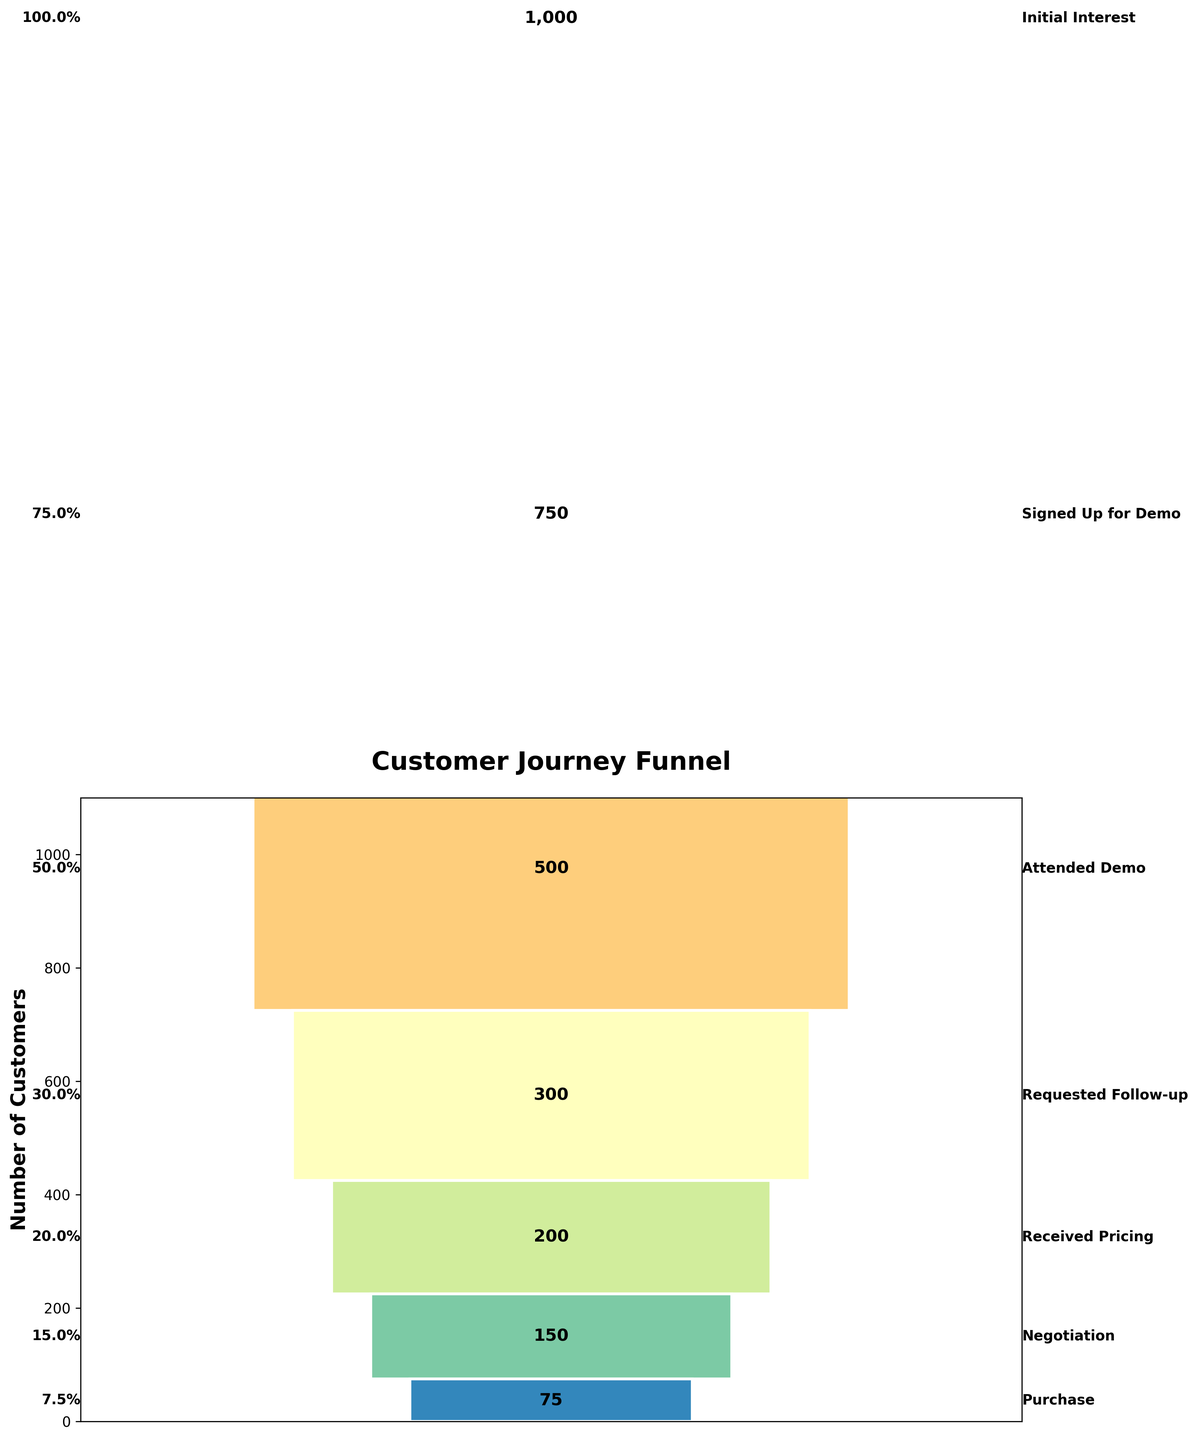What's the title of the funnel chart? The title is usually placed at the top of the chart. The figure shows "Customer Journey Funnel" as the title, positioned prominently at the top of the chart.
Answer: Customer Journey Funnel How many customers signed up for the demo? The funnel chart shows counts at each stage. The count for "Signed Up for Demo" is 750, found near the top of the funnel.
Answer: 750 What is the proportion of customers who requested a follow-up after attending the demo? To find the proportion, divide the number of customers who "Requested Follow-up" (300) by those who "Attended Demo" (500). Then convert to percentage: (300 / 500) * 100 = 60%.
Answer: 60% Which stage has the largest drop in customer count? By observing the counts, we see the largest decrease between "Signed Up for Demo" (750) and "Attended Demo" (500), a difference of 250 customers. This is the largest drop among all stages.
Answer: Signed Up for Demo to Attended Demo How many stages show more than a 50% drop from the initial interest stage? We can calculate the percentage drop at each stage. Any stage with less than 500 customers (which is 50% of 1000) counts. From 1000, the stages "Received Pricing" (200), "Negotiation" (150), and "Purchase" (75) all show more than a 50% drop. There are three such stages.
Answer: 3 What's the percentage of customers that reached the final purchase stage from the initial interest? To calculate the percentage, divide the number of purchases (75) by the number of initial interests (1000) and multiply by 100: (75 / 1000) * 100 = 7.5%.
Answer: 7.5% Which stage sees the smallest decrease in customer count? The smallest decrease in customer count can be found by comparing consecutive stages. The reduction from "Negotiation" (150) to "Purchase" (75) is 75, which is smaller than the other drops.
Answer: Negotiation to Purchase What’s the number of stages in the customer journey funnel? The chart shows stages from "Initial Interest" to "Purchase" listed in sequential order. Counting these, we have 7 stages.
Answer: 7 What percentage of customers who received pricing went on to negotiations? Calculate the percentage of those who moved from "Received Pricing" (200) to "Negotiation" (150): (150 / 200) * 100 = 75%.
Answer: 75% Is the number of customers at each stage increasing or decreasing down the funnel? Examining the data, we see that the number of customers decreases at each successive stage, as the funnel narrows.
Answer: Decreasing 